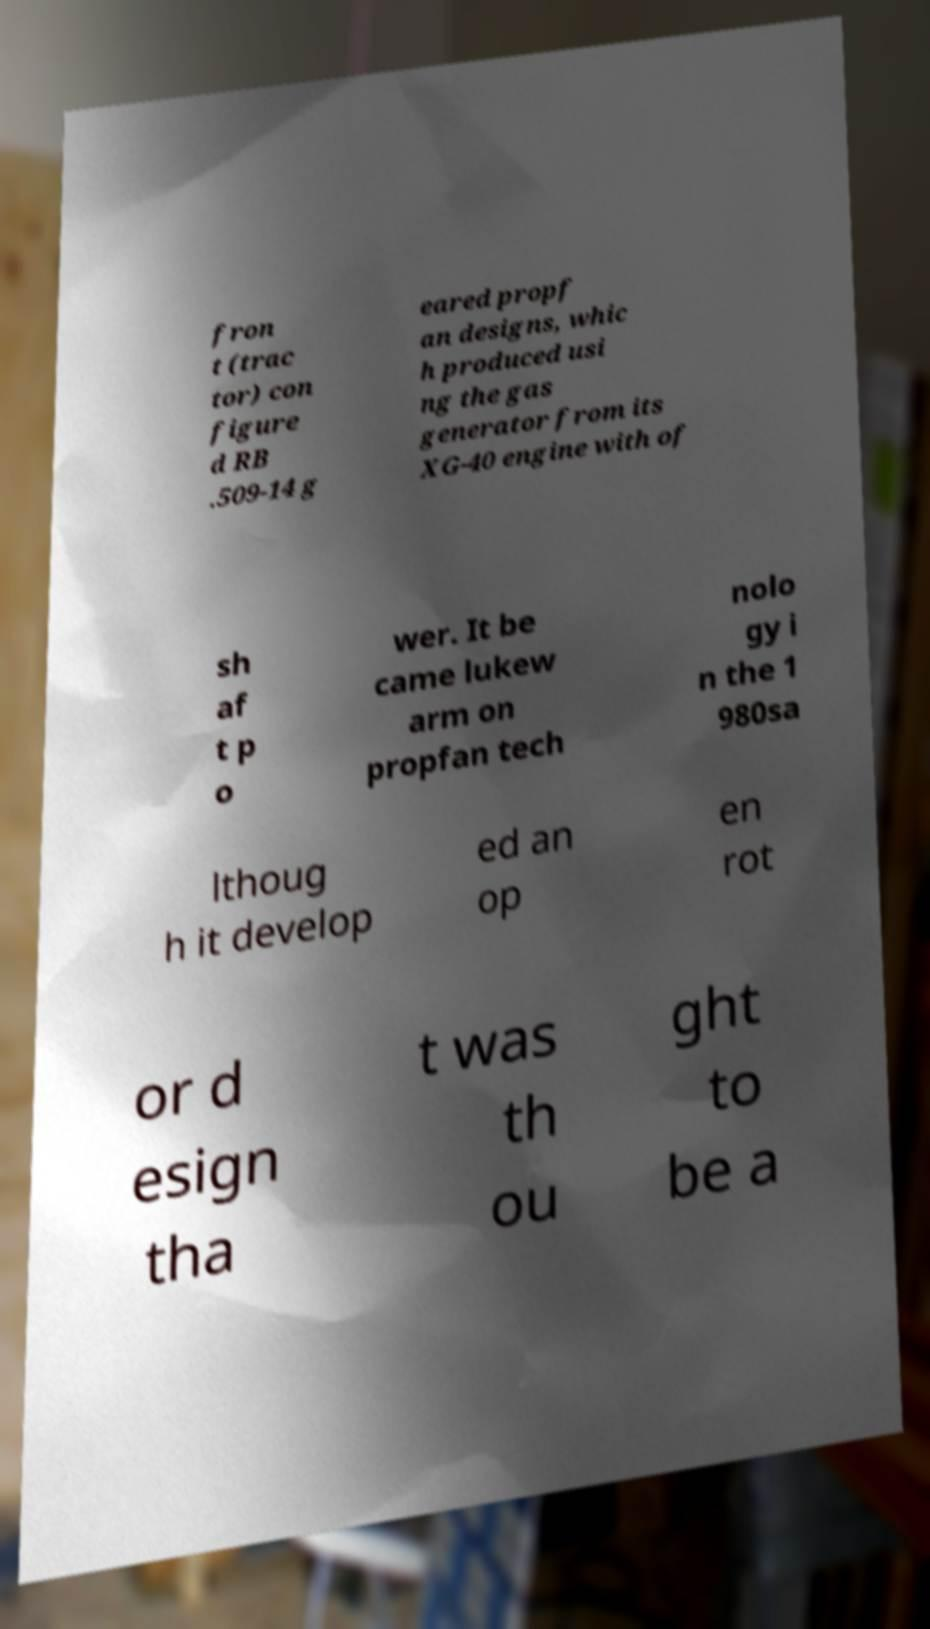What messages or text are displayed in this image? I need them in a readable, typed format. fron t (trac tor) con figure d RB .509-14 g eared propf an designs, whic h produced usi ng the gas generator from its XG-40 engine with of sh af t p o wer. It be came lukew arm on propfan tech nolo gy i n the 1 980sa lthoug h it develop ed an op en rot or d esign tha t was th ou ght to be a 